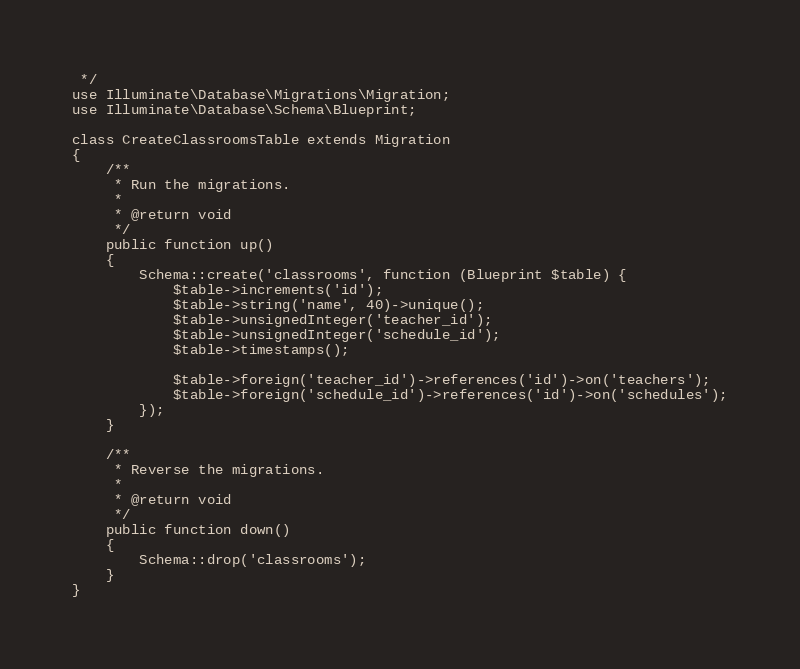Convert code to text. <code><loc_0><loc_0><loc_500><loc_500><_PHP_> */
use Illuminate\Database\Migrations\Migration;
use Illuminate\Database\Schema\Blueprint;

class CreateClassroomsTable extends Migration
{
    /**
     * Run the migrations.
     *
     * @return void
     */
    public function up()
    {
        Schema::create('classrooms', function (Blueprint $table) {
            $table->increments('id');
            $table->string('name', 40)->unique();
            $table->unsignedInteger('teacher_id');
            $table->unsignedInteger('schedule_id');
            $table->timestamps();

            $table->foreign('teacher_id')->references('id')->on('teachers');
            $table->foreign('schedule_id')->references('id')->on('schedules');
        });
    }

    /**
     * Reverse the migrations.
     *
     * @return void
     */
    public function down()
    {
        Schema::drop('classrooms');
    }
}
</code> 